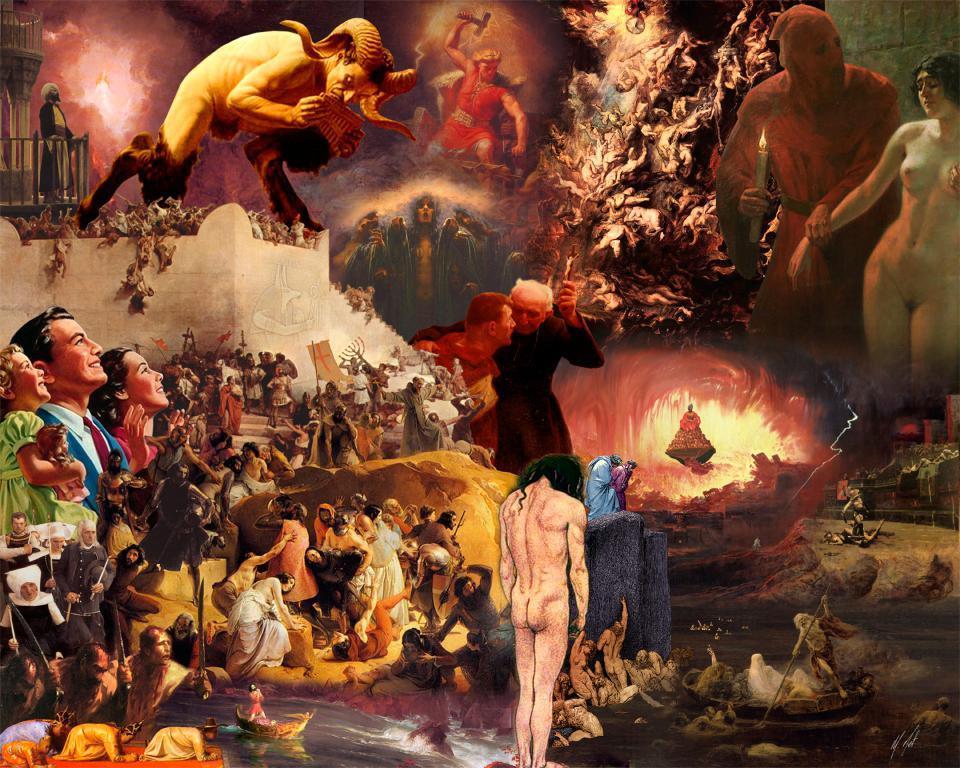How would you summarize this image in a sentence or two? In this image I can see an art. It is looking like a painting. I can see many people in the painting. 